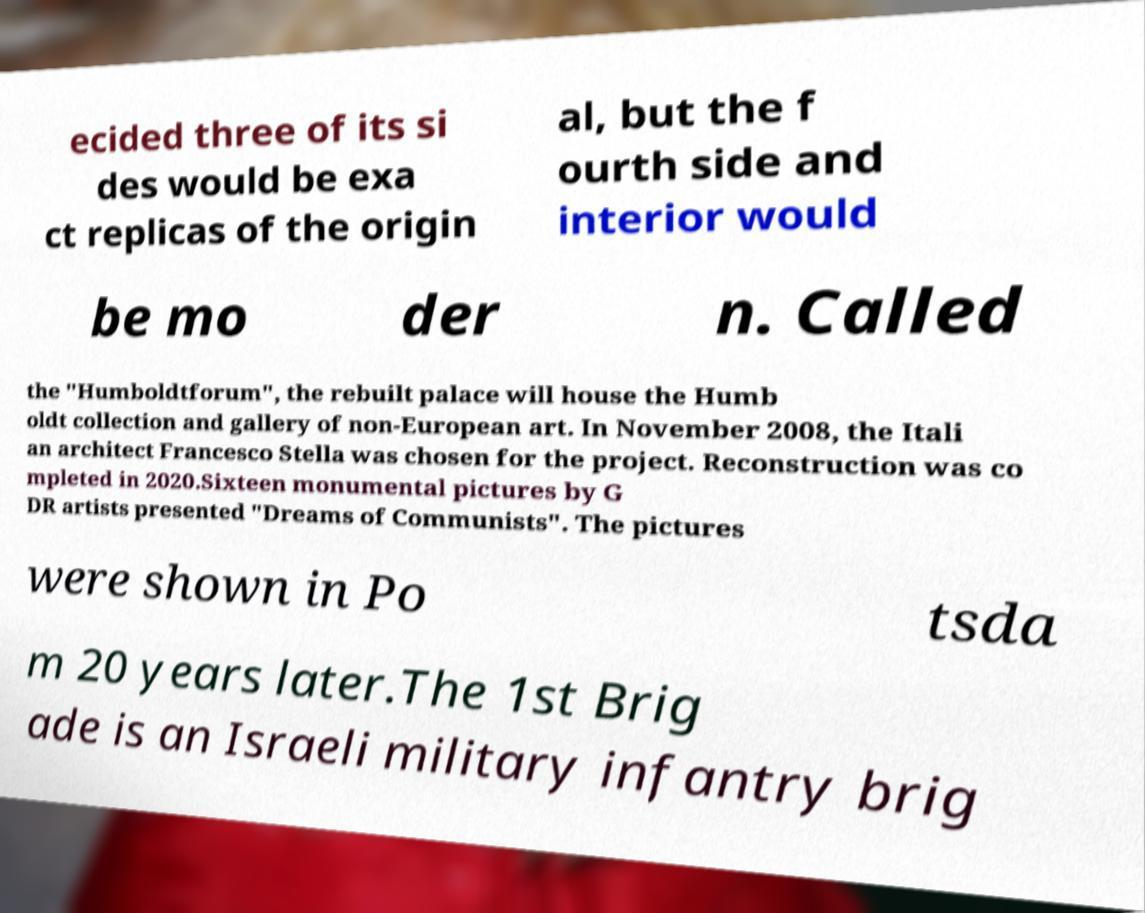Please identify and transcribe the text found in this image. ecided three of its si des would be exa ct replicas of the origin al, but the f ourth side and interior would be mo der n. Called the "Humboldtforum", the rebuilt palace will house the Humb oldt collection and gallery of non-European art. In November 2008, the Itali an architect Francesco Stella was chosen for the project. Reconstruction was co mpleted in 2020.Sixteen monumental pictures by G DR artists presented "Dreams of Communists". The pictures were shown in Po tsda m 20 years later.The 1st Brig ade is an Israeli military infantry brig 